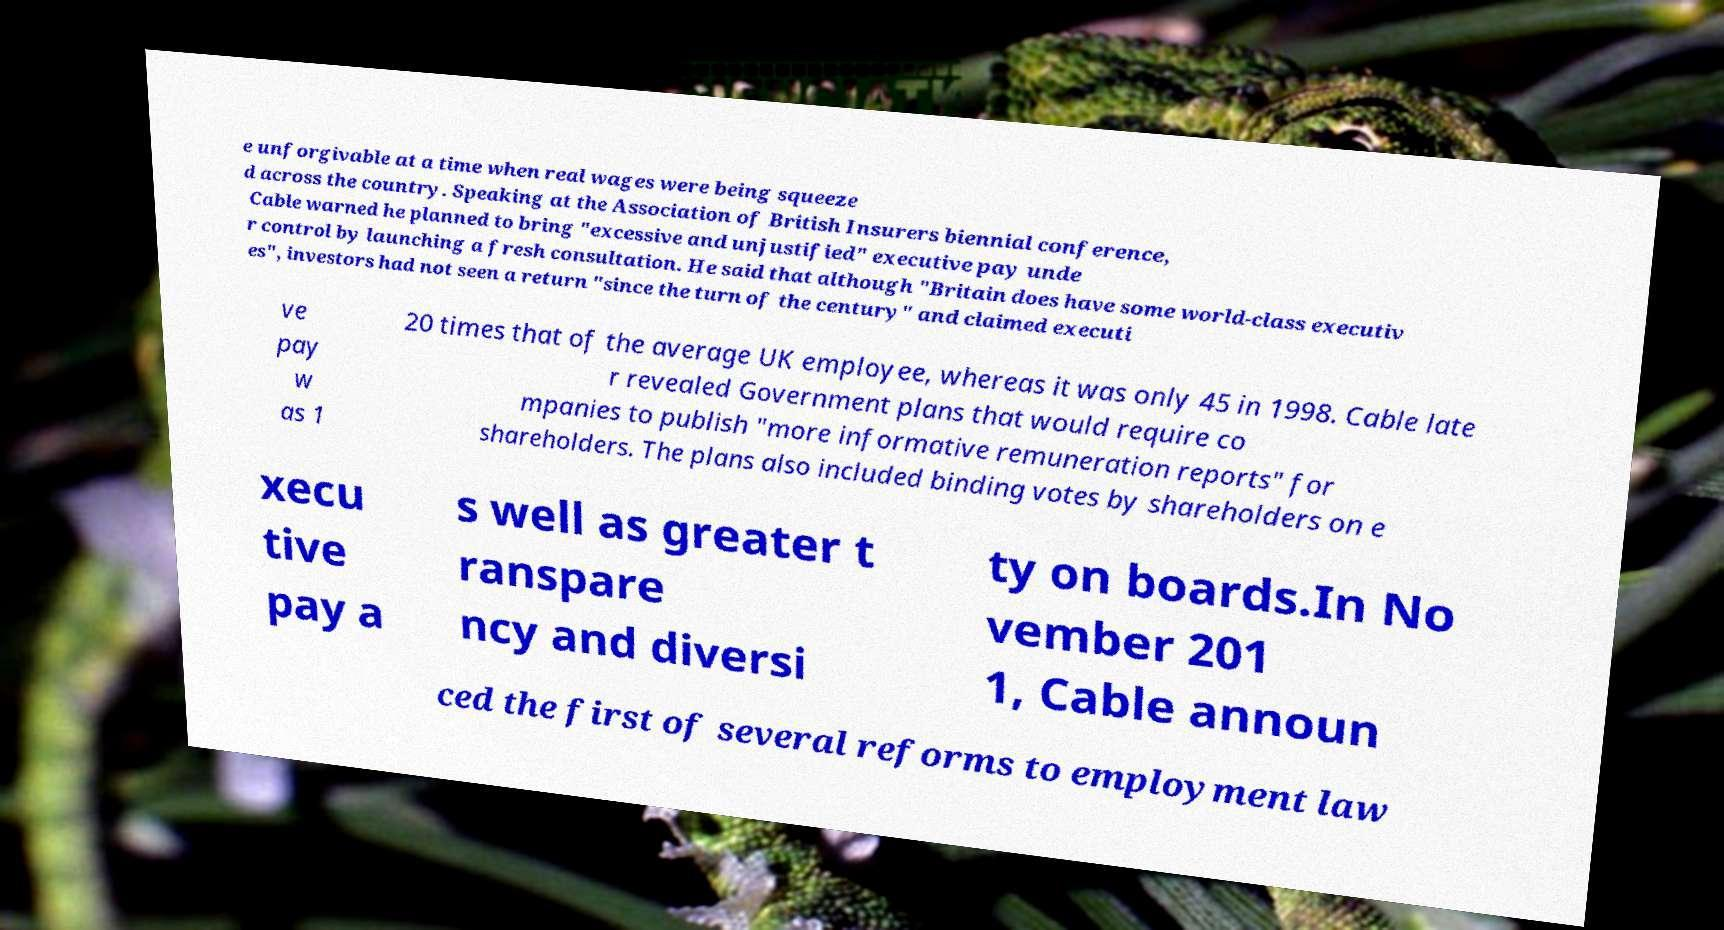Can you accurately transcribe the text from the provided image for me? e unforgivable at a time when real wages were being squeeze d across the country. Speaking at the Association of British Insurers biennial conference, Cable warned he planned to bring "excessive and unjustified" executive pay unde r control by launching a fresh consultation. He said that although "Britain does have some world-class executiv es", investors had not seen a return "since the turn of the century" and claimed executi ve pay w as 1 20 times that of the average UK employee, whereas it was only 45 in 1998. Cable late r revealed Government plans that would require co mpanies to publish "more informative remuneration reports" for shareholders. The plans also included binding votes by shareholders on e xecu tive pay a s well as greater t ranspare ncy and diversi ty on boards.In No vember 201 1, Cable announ ced the first of several reforms to employment law 